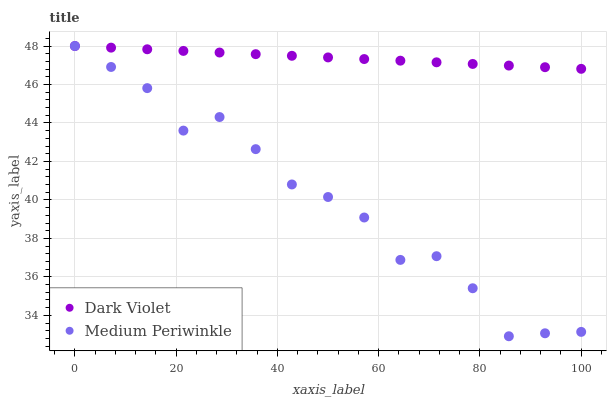Does Medium Periwinkle have the minimum area under the curve?
Answer yes or no. Yes. Does Dark Violet have the maximum area under the curve?
Answer yes or no. Yes. Does Dark Violet have the minimum area under the curve?
Answer yes or no. No. Is Dark Violet the smoothest?
Answer yes or no. Yes. Is Medium Periwinkle the roughest?
Answer yes or no. Yes. Is Dark Violet the roughest?
Answer yes or no. No. Does Medium Periwinkle have the lowest value?
Answer yes or no. Yes. Does Dark Violet have the lowest value?
Answer yes or no. No. Does Dark Violet have the highest value?
Answer yes or no. Yes. Does Medium Periwinkle intersect Dark Violet?
Answer yes or no. Yes. Is Medium Periwinkle less than Dark Violet?
Answer yes or no. No. Is Medium Periwinkle greater than Dark Violet?
Answer yes or no. No. 